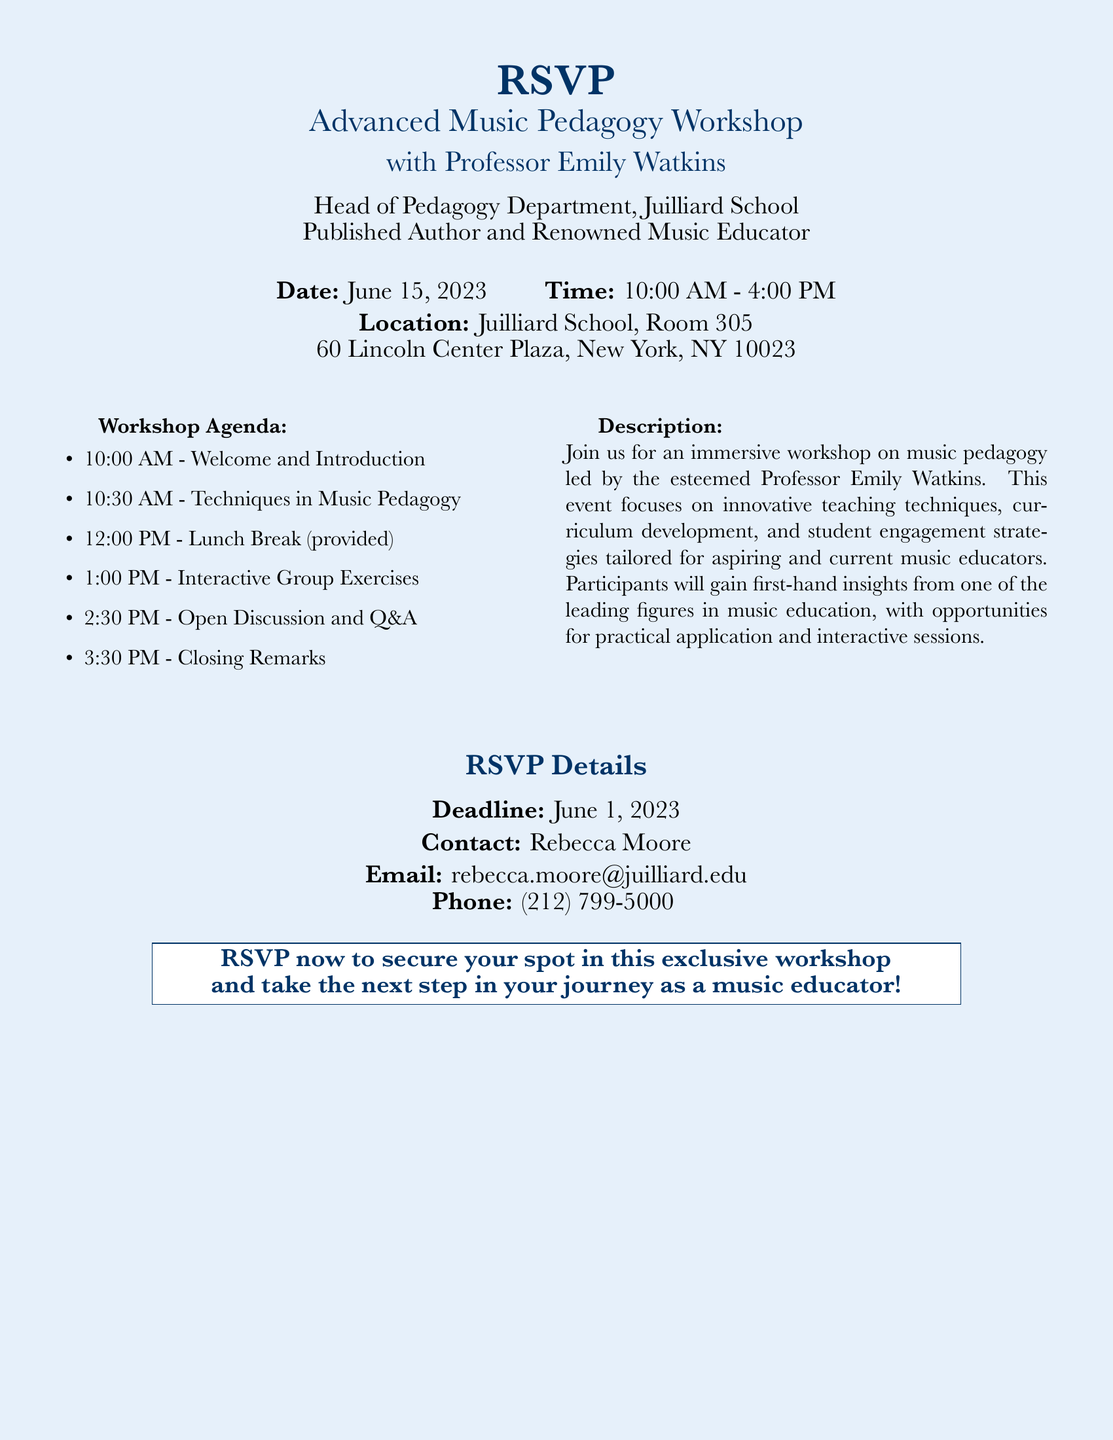What is the date of the workshop? The date is explicitly stated in the document as June 15, 2023.
Answer: June 15, 2023 Who is the workshop led by? The document identifies Professor Emily Watkins as the instructor for the workshop.
Answer: Professor Emily Watkins What time does the workshop start? The starting time is noted in the document, highlighting that it begins at 10:00 AM.
Answer: 10:00 AM What is provided during the lunch break? The document indicates that a lunch break will be provided during the workshop.
Answer: Lunch What is the last session in the workshop agenda? The agenda lists the final session as "Closing Remarks" scheduled for 3:30 PM.
Answer: Closing Remarks What is the RSVP deadline? The document specifies that the RSVP deadline is June 1, 2023.
Answer: June 1, 2023 What is the main focus of the workshop? The description notes that the workshop focuses on innovative teaching techniques and strategies for music educators.
Answer: Innovative teaching techniques Where is the workshop held? The location of the workshop is detailed in the document, stating it is at Juilliard School, Room 305.
Answer: Juilliard School, Room 305 Who should be contacted for more information? The document lists Rebecca Moore as the contact for further inquiries regarding the workshop.
Answer: Rebecca Moore 